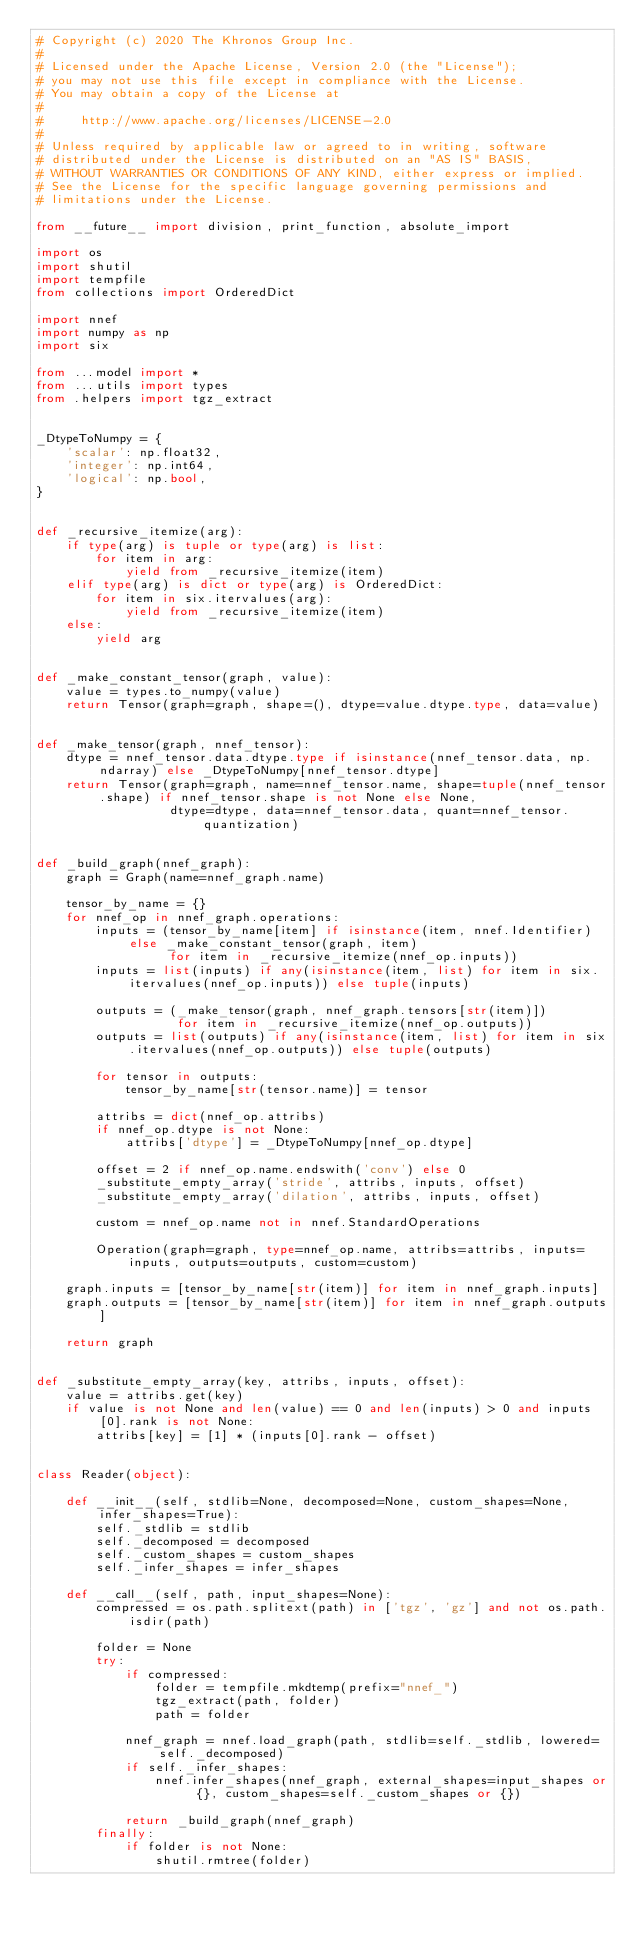Convert code to text. <code><loc_0><loc_0><loc_500><loc_500><_Python_># Copyright (c) 2020 The Khronos Group Inc.
#
# Licensed under the Apache License, Version 2.0 (the "License");
# you may not use this file except in compliance with the License.
# You may obtain a copy of the License at
#
#     http://www.apache.org/licenses/LICENSE-2.0
#
# Unless required by applicable law or agreed to in writing, software
# distributed under the License is distributed on an "AS IS" BASIS,
# WITHOUT WARRANTIES OR CONDITIONS OF ANY KIND, either express or implied.
# See the License for the specific language governing permissions and
# limitations under the License.

from __future__ import division, print_function, absolute_import

import os
import shutil
import tempfile
from collections import OrderedDict

import nnef
import numpy as np
import six

from ...model import *
from ...utils import types
from .helpers import tgz_extract


_DtypeToNumpy = {
    'scalar': np.float32,
    'integer': np.int64,
    'logical': np.bool,
}


def _recursive_itemize(arg):
    if type(arg) is tuple or type(arg) is list:
        for item in arg:
            yield from _recursive_itemize(item)
    elif type(arg) is dict or type(arg) is OrderedDict:
        for item in six.itervalues(arg):
            yield from _recursive_itemize(item)
    else:
        yield arg


def _make_constant_tensor(graph, value):
    value = types.to_numpy(value)
    return Tensor(graph=graph, shape=(), dtype=value.dtype.type, data=value)


def _make_tensor(graph, nnef_tensor):
    dtype = nnef_tensor.data.dtype.type if isinstance(nnef_tensor.data, np.ndarray) else _DtypeToNumpy[nnef_tensor.dtype]
    return Tensor(graph=graph, name=nnef_tensor.name, shape=tuple(nnef_tensor.shape) if nnef_tensor.shape is not None else None,
                  dtype=dtype, data=nnef_tensor.data, quant=nnef_tensor.quantization)


def _build_graph(nnef_graph):
    graph = Graph(name=nnef_graph.name)

    tensor_by_name = {}
    for nnef_op in nnef_graph.operations:
        inputs = (tensor_by_name[item] if isinstance(item, nnef.Identifier) else _make_constant_tensor(graph, item)
                  for item in _recursive_itemize(nnef_op.inputs))
        inputs = list(inputs) if any(isinstance(item, list) for item in six.itervalues(nnef_op.inputs)) else tuple(inputs)

        outputs = (_make_tensor(graph, nnef_graph.tensors[str(item)])
                   for item in _recursive_itemize(nnef_op.outputs))
        outputs = list(outputs) if any(isinstance(item, list) for item in six.itervalues(nnef_op.outputs)) else tuple(outputs)

        for tensor in outputs:
            tensor_by_name[str(tensor.name)] = tensor

        attribs = dict(nnef_op.attribs)
        if nnef_op.dtype is not None:
            attribs['dtype'] = _DtypeToNumpy[nnef_op.dtype]

        offset = 2 if nnef_op.name.endswith('conv') else 0
        _substitute_empty_array('stride', attribs, inputs, offset)
        _substitute_empty_array('dilation', attribs, inputs, offset)

        custom = nnef_op.name not in nnef.StandardOperations

        Operation(graph=graph, type=nnef_op.name, attribs=attribs, inputs=inputs, outputs=outputs, custom=custom)

    graph.inputs = [tensor_by_name[str(item)] for item in nnef_graph.inputs]
    graph.outputs = [tensor_by_name[str(item)] for item in nnef_graph.outputs]

    return graph


def _substitute_empty_array(key, attribs, inputs, offset):
    value = attribs.get(key)
    if value is not None and len(value) == 0 and len(inputs) > 0 and inputs[0].rank is not None:
        attribs[key] = [1] * (inputs[0].rank - offset)


class Reader(object):

    def __init__(self, stdlib=None, decomposed=None, custom_shapes=None, infer_shapes=True):
        self._stdlib = stdlib
        self._decomposed = decomposed
        self._custom_shapes = custom_shapes
        self._infer_shapes = infer_shapes

    def __call__(self, path, input_shapes=None):
        compressed = os.path.splitext(path) in ['tgz', 'gz'] and not os.path.isdir(path)

        folder = None
        try:
            if compressed:
                folder = tempfile.mkdtemp(prefix="nnef_")
                tgz_extract(path, folder)
                path = folder

            nnef_graph = nnef.load_graph(path, stdlib=self._stdlib, lowered=self._decomposed)
            if self._infer_shapes:
                nnef.infer_shapes(nnef_graph, external_shapes=input_shapes or {}, custom_shapes=self._custom_shapes or {})

            return _build_graph(nnef_graph)
        finally:
            if folder is not None:
                shutil.rmtree(folder)
</code> 